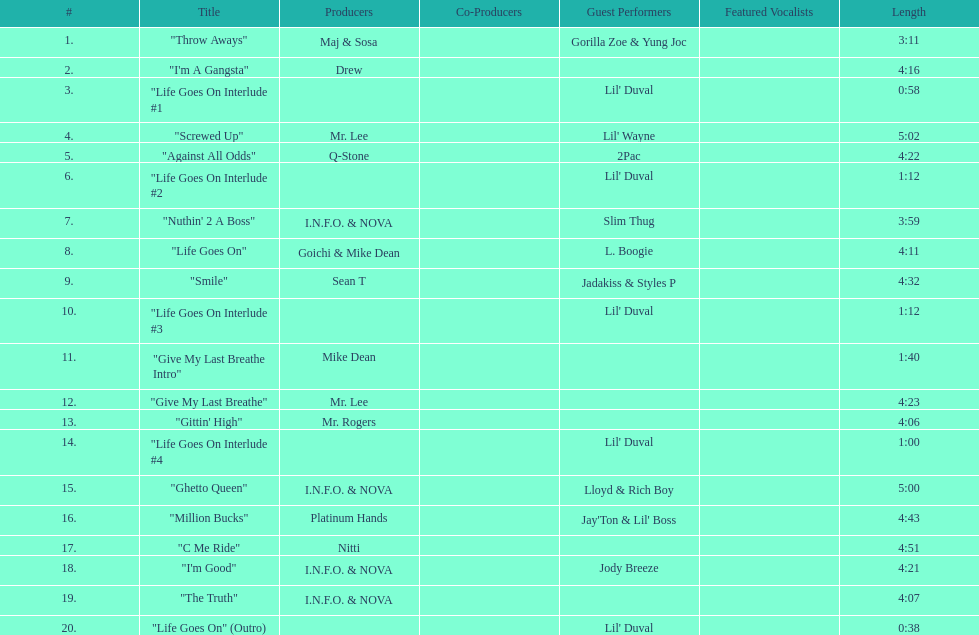What is the total number of tracks on the album? 20. 